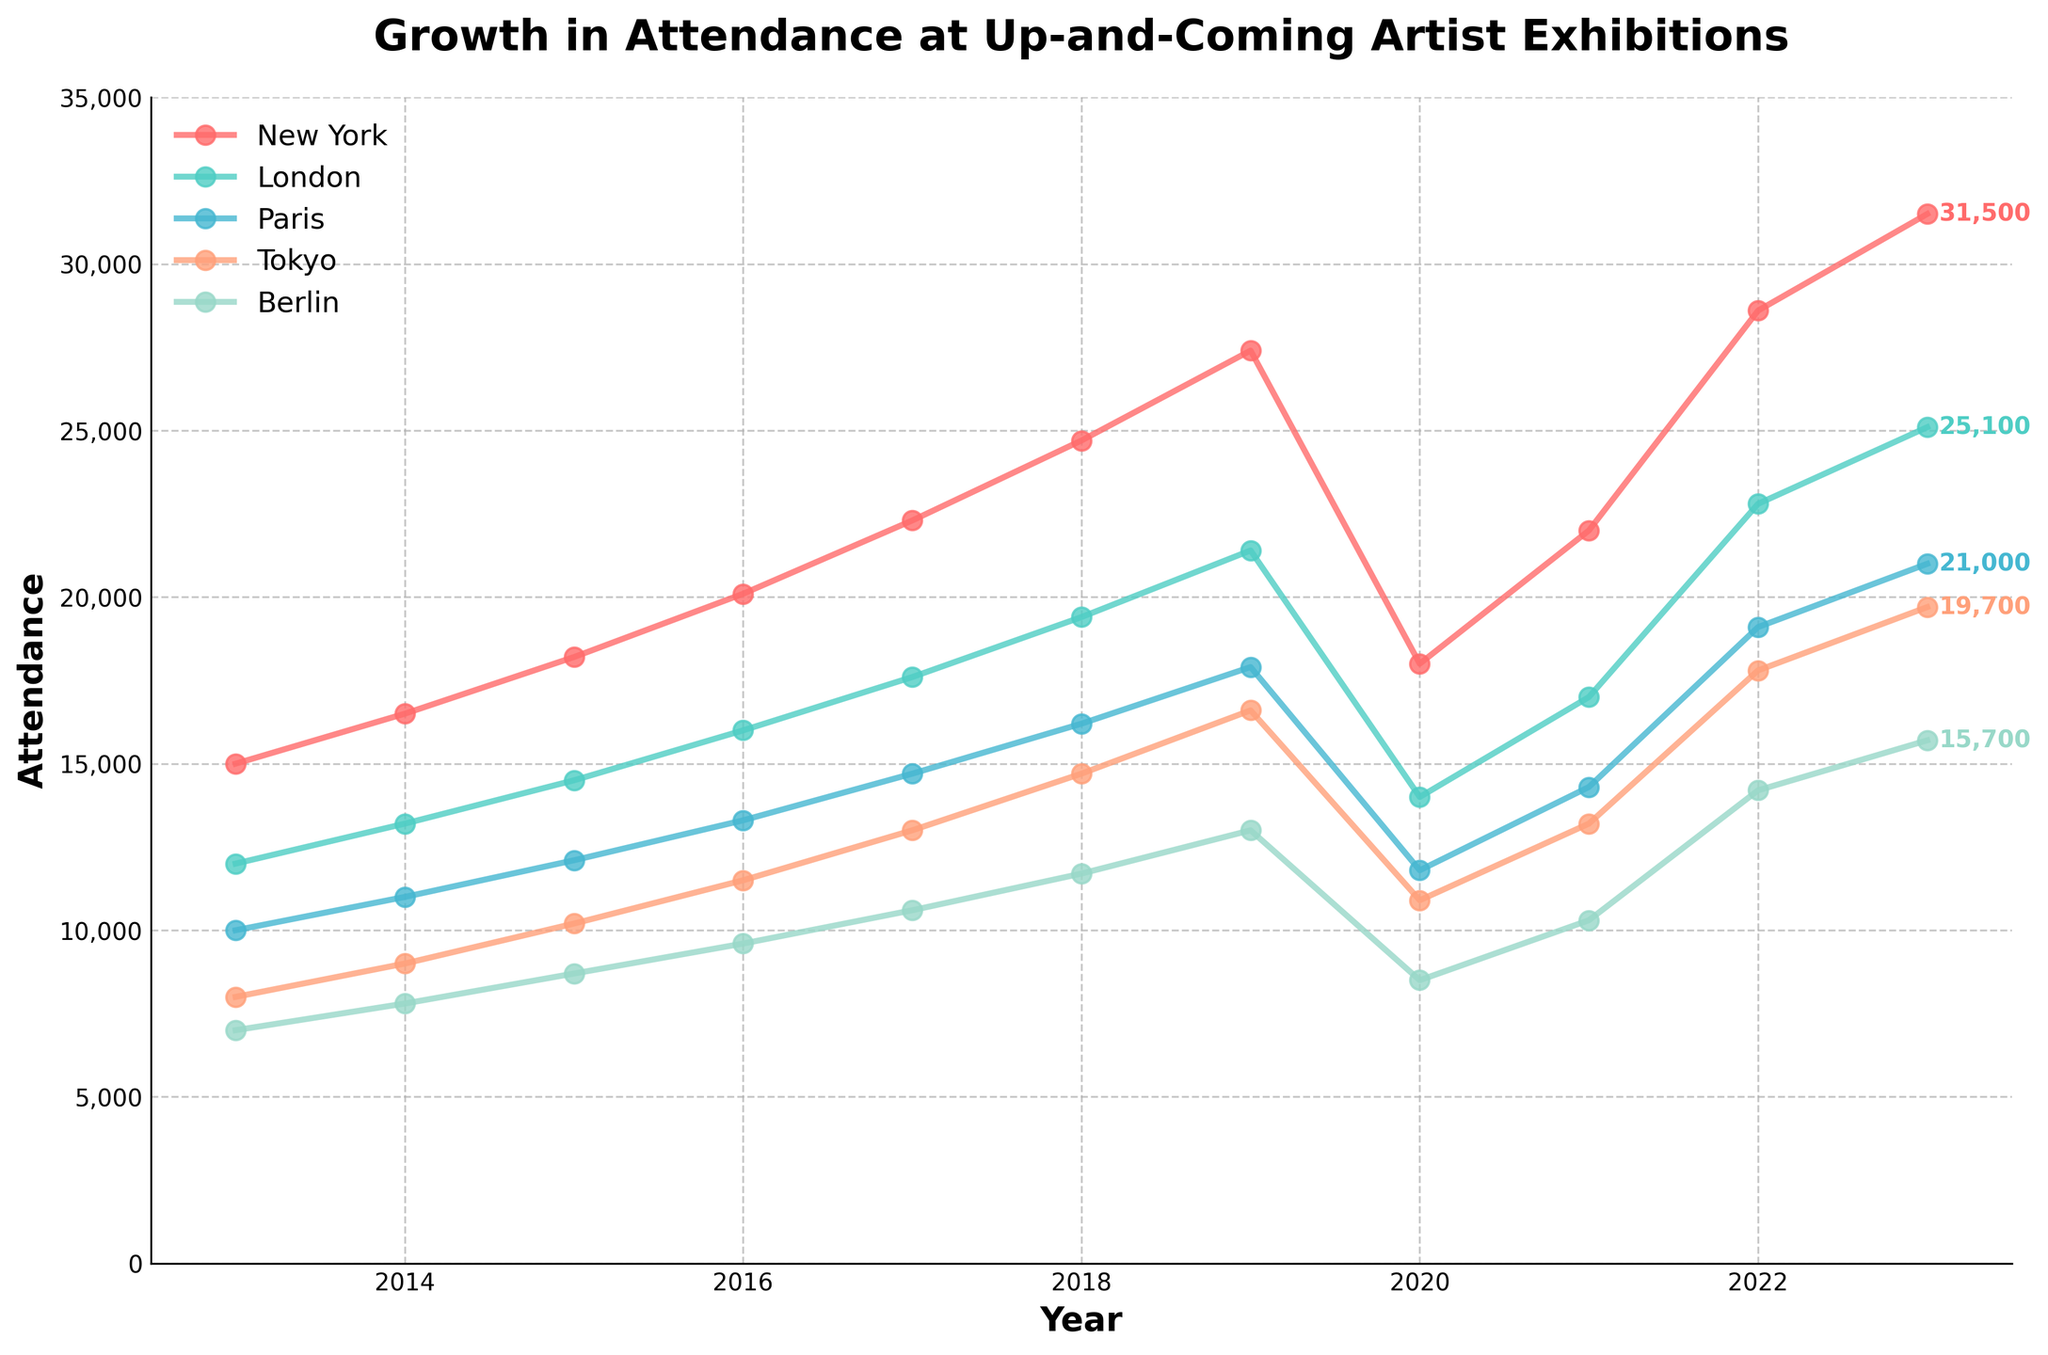what is the difference in attendance between New York and Berlin in 2023? To find the difference in attendance between New York and Berlin in 2023, subtract the attendance of Berlin (15,700) from that of New York (31,500). 31,500 - 15,700 = 15,800
Answer: 15,800 Which city had the highest attendance in 2022? To determine the highest attendance in 2022, compare the attendance numbers for all cities in that year: New York (28,600), London (22,800), Paris (19,100), Tokyo (17,800), and Berlin (14,200). New York had the highest attendance.
Answer: New York Did any city experience a decrease in attendance from 2019 to 2020? To identify if a city experienced a decrease in attendance between 2019 and 2020, compare the attendance numbers for each city from those years. All cities show a decrease: New York (27,400 to 18,000), London (21,400 to 14,000), Paris (17,900 to 11,800), Tokyo (16,600 to 10,900), and Berlin (13,000 to 8,500).
Answer: All cities What's the average attendance across all cities in 2017? To find the average attendance across all cities in 2017, sum the attendance numbers for all cities in that year and divide by the number of cities: (22,300 + 17,600 + 14,700 + 13,000 + 10,600) / 5 = 78,200 / 5 = 15,640
Answer: 15,640 How much did Tokyo's attendance grow from 2013 to 2023? To calculate Tokyo's attendance growth from 2013 to 2023, subtract the 2013 attendance (8,000) from the 2023 attendance (19,700): 19,700 - 8,000 = 11,700
Answer: 11,700 Which city had the lowest attendance in 2015? Compare the attendance numbers for all cities in 2015: New York (18,200), London (14,500), Paris (12,100), Tokyo (10,200), and Berlin (8,700). Berlin had the lowest attendance.
Answer: Berlin What's the total attendance for all cities combined in 2020? To find the total attendance for all cities in 2020, sum the attendance numbers for each city: 18,000 (New York) + 14,000 (London) + 11,800 (Paris) + 10,900 (Tokyo) + 8,500 (Berlin) = 63,200
Answer: 63,200 What's the growth rate percentage of London's attendance from 2013 to 2023? The growth rate is calculated as (final value - initial value) / initial value * 100. For London, (25,100 - 12,000) / 12,000 * 100 = 13,100 / 12,000 * 100 = 109.17%
Answer: 109.17% How did Paris's attendance change from 2018 to 2023 compared to Berlin's attendance? To find and compare the change, subtract the 2018 attendance from the 2023 attendance for both cities. For Paris: 21,000 - 16,200 = 4,800 increase. For Berlin: 15,700 - 11,700 = 4,000 increase. Paris had a higher increase.
Answer: Paris +4,800, Berlin +4,000 Which year did New York have the smallest attendance increase compared to the previous year? Observe the difference in attendance between consecutive years for New York and compare these differences: from 2013 to 2014 (1,500), 2014 to 2015 (1,700), 2015 to 2016 (1,900), 2016 to 2017 (2,200), 2017 to 2018 (2,400), 2018 to 2019 (2,700), 2019 to 2020 (-9,400), 2020 to 2021 (4,000), 2021 to 2022 (6,600), and 2022 to 2023 (2,900). The smallest increase is between 2014 and 2015 (1,700).
Answer: 2014 to 2015 